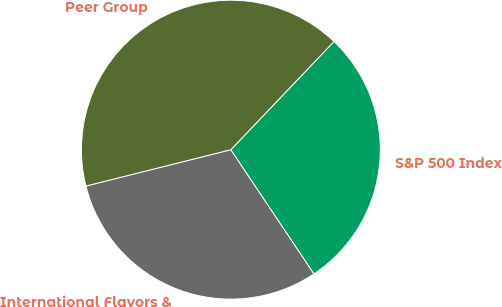Convert chart. <chart><loc_0><loc_0><loc_500><loc_500><pie_chart><fcel>International Flavors &<fcel>S&P 500 Index<fcel>Peer Group<nl><fcel>30.48%<fcel>28.49%<fcel>41.03%<nl></chart> 